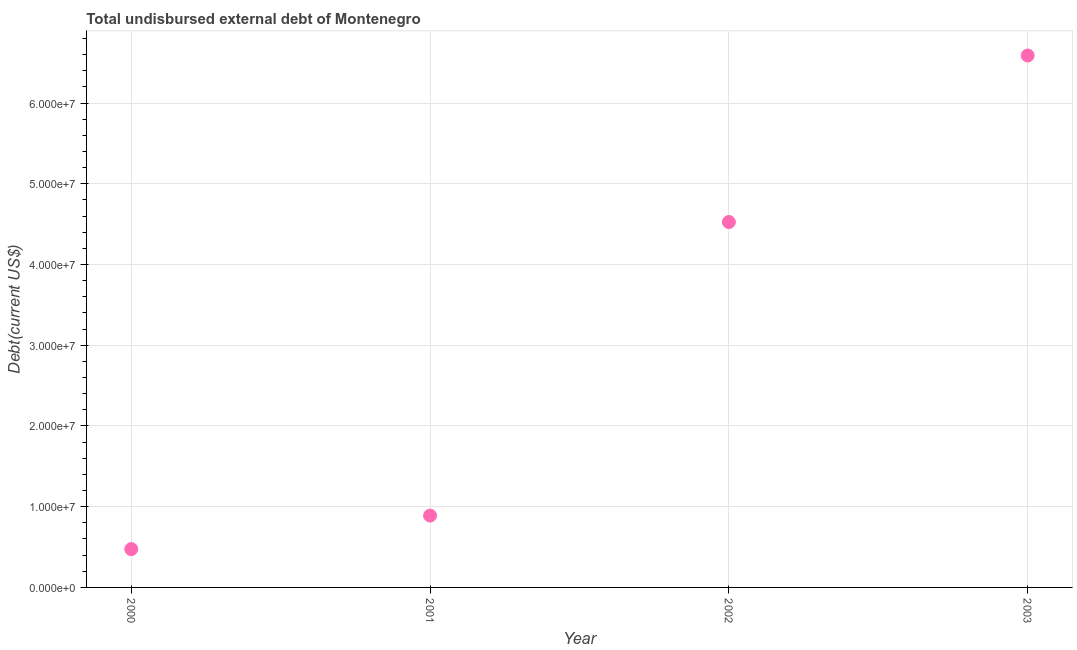What is the total debt in 2003?
Your answer should be compact. 6.59e+07. Across all years, what is the maximum total debt?
Offer a very short reply. 6.59e+07. Across all years, what is the minimum total debt?
Make the answer very short. 4.75e+06. In which year was the total debt maximum?
Ensure brevity in your answer.  2003. In which year was the total debt minimum?
Your response must be concise. 2000. What is the sum of the total debt?
Keep it short and to the point. 1.25e+08. What is the difference between the total debt in 2000 and 2002?
Provide a short and direct response. -4.05e+07. What is the average total debt per year?
Make the answer very short. 3.12e+07. What is the median total debt?
Your answer should be very brief. 2.71e+07. In how many years, is the total debt greater than 22000000 US$?
Your answer should be compact. 2. Do a majority of the years between 2002 and 2001 (inclusive) have total debt greater than 36000000 US$?
Offer a very short reply. No. What is the ratio of the total debt in 2001 to that in 2003?
Keep it short and to the point. 0.14. Is the total debt in 2002 less than that in 2003?
Keep it short and to the point. Yes. What is the difference between the highest and the second highest total debt?
Offer a very short reply. 2.06e+07. Is the sum of the total debt in 2000 and 2003 greater than the maximum total debt across all years?
Make the answer very short. Yes. What is the difference between the highest and the lowest total debt?
Ensure brevity in your answer.  6.12e+07. Does the total debt monotonically increase over the years?
Ensure brevity in your answer.  Yes. How many years are there in the graph?
Ensure brevity in your answer.  4. What is the title of the graph?
Provide a succinct answer. Total undisbursed external debt of Montenegro. What is the label or title of the Y-axis?
Offer a very short reply. Debt(current US$). What is the Debt(current US$) in 2000?
Keep it short and to the point. 4.75e+06. What is the Debt(current US$) in 2001?
Provide a short and direct response. 8.90e+06. What is the Debt(current US$) in 2002?
Your answer should be very brief. 4.53e+07. What is the Debt(current US$) in 2003?
Your response must be concise. 6.59e+07. What is the difference between the Debt(current US$) in 2000 and 2001?
Give a very brief answer. -4.16e+06. What is the difference between the Debt(current US$) in 2000 and 2002?
Your answer should be compact. -4.05e+07. What is the difference between the Debt(current US$) in 2000 and 2003?
Give a very brief answer. -6.12e+07. What is the difference between the Debt(current US$) in 2001 and 2002?
Provide a succinct answer. -3.64e+07. What is the difference between the Debt(current US$) in 2001 and 2003?
Give a very brief answer. -5.70e+07. What is the difference between the Debt(current US$) in 2002 and 2003?
Offer a terse response. -2.06e+07. What is the ratio of the Debt(current US$) in 2000 to that in 2001?
Your response must be concise. 0.53. What is the ratio of the Debt(current US$) in 2000 to that in 2002?
Keep it short and to the point. 0.1. What is the ratio of the Debt(current US$) in 2000 to that in 2003?
Keep it short and to the point. 0.07. What is the ratio of the Debt(current US$) in 2001 to that in 2002?
Give a very brief answer. 0.2. What is the ratio of the Debt(current US$) in 2001 to that in 2003?
Keep it short and to the point. 0.14. What is the ratio of the Debt(current US$) in 2002 to that in 2003?
Your response must be concise. 0.69. 